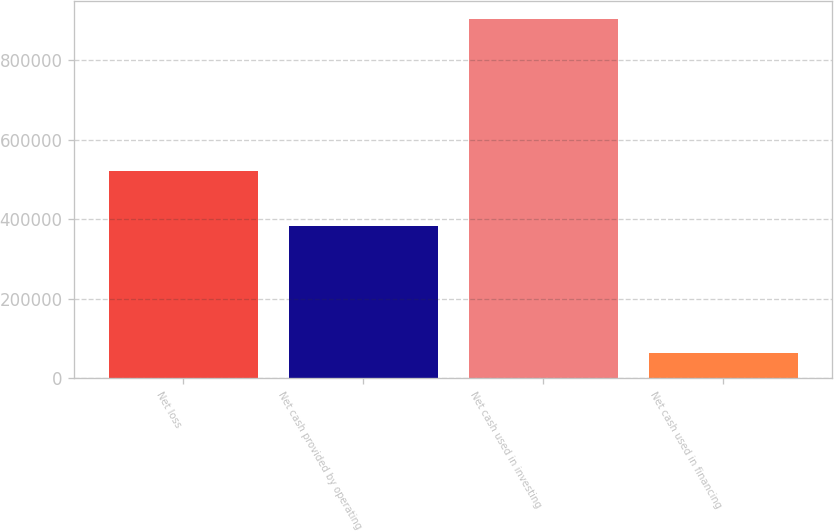<chart> <loc_0><loc_0><loc_500><loc_500><bar_chart><fcel>Net loss<fcel>Net cash provided by operating<fcel>Net cash used in investing<fcel>Net cash used in financing<nl><fcel>521031<fcel>383066<fcel>902421<fcel>62998<nl></chart> 